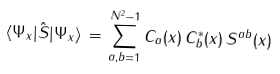Convert formula to latex. <formula><loc_0><loc_0><loc_500><loc_500>\langle \Psi _ { x } | \hat { S } | \Psi _ { x } \rangle \, = \, \sum _ { a , b = 1 } ^ { N ^ { 2 } - 1 } C _ { a } ( x ) \, C ^ { * } _ { b } ( x ) \, S ^ { a b } ( x )</formula> 